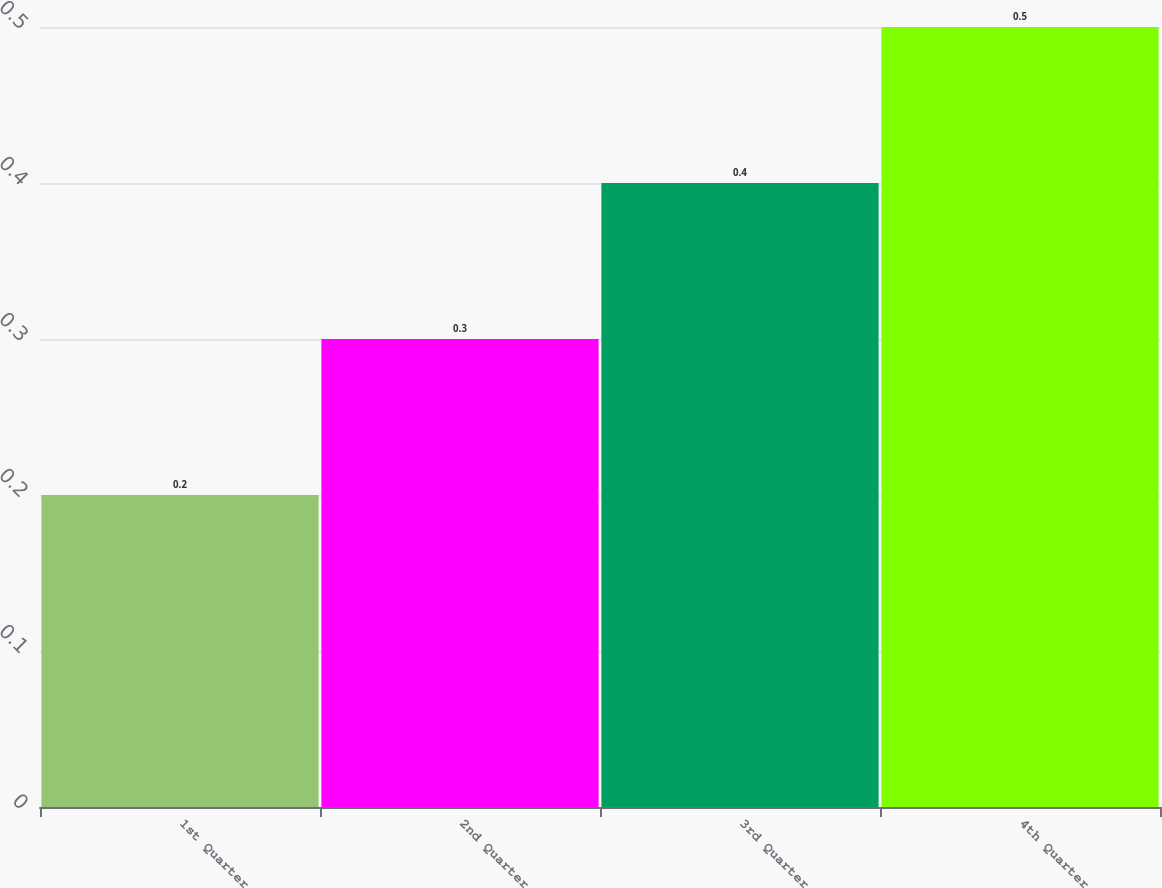Convert chart to OTSL. <chart><loc_0><loc_0><loc_500><loc_500><bar_chart><fcel>1st Quarter<fcel>2nd Quarter<fcel>3rd Quarter<fcel>4th Quarter<nl><fcel>0.2<fcel>0.3<fcel>0.4<fcel>0.5<nl></chart> 